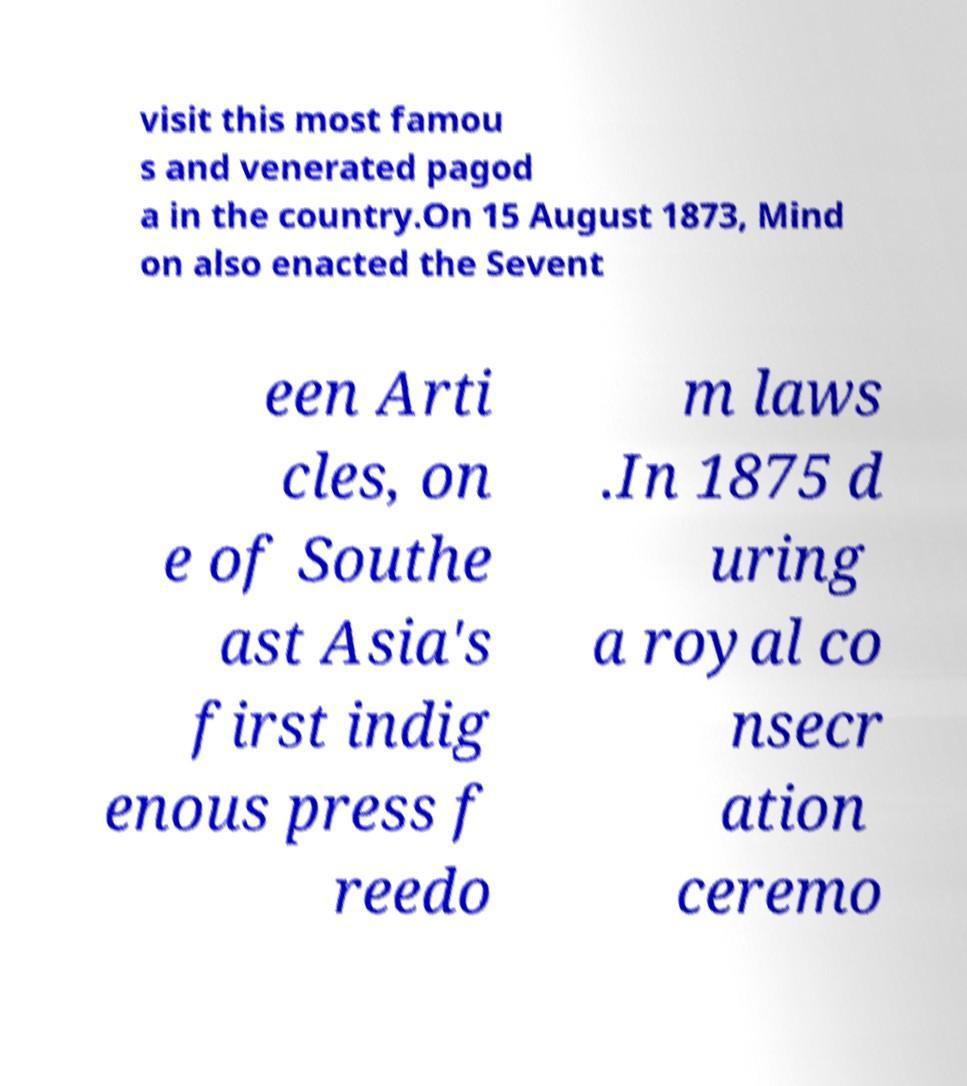What messages or text are displayed in this image? I need them in a readable, typed format. visit this most famou s and venerated pagod a in the country.On 15 August 1873, Mind on also enacted the Sevent een Arti cles, on e of Southe ast Asia's first indig enous press f reedo m laws .In 1875 d uring a royal co nsecr ation ceremo 